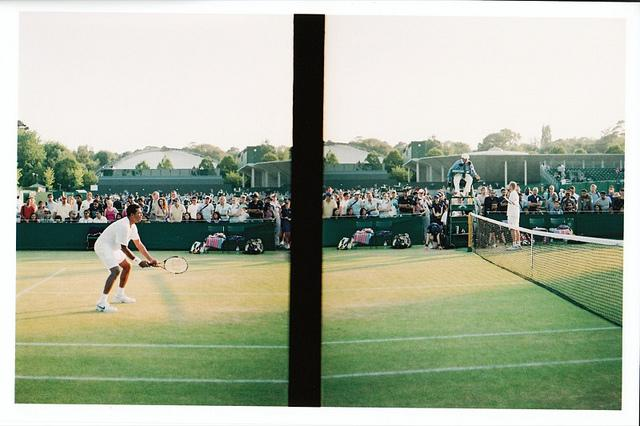Who is the person sitting high above the tennis net? Please explain your reasoning. referee. The chair umpire is responsible for making sure all the play is fair. 